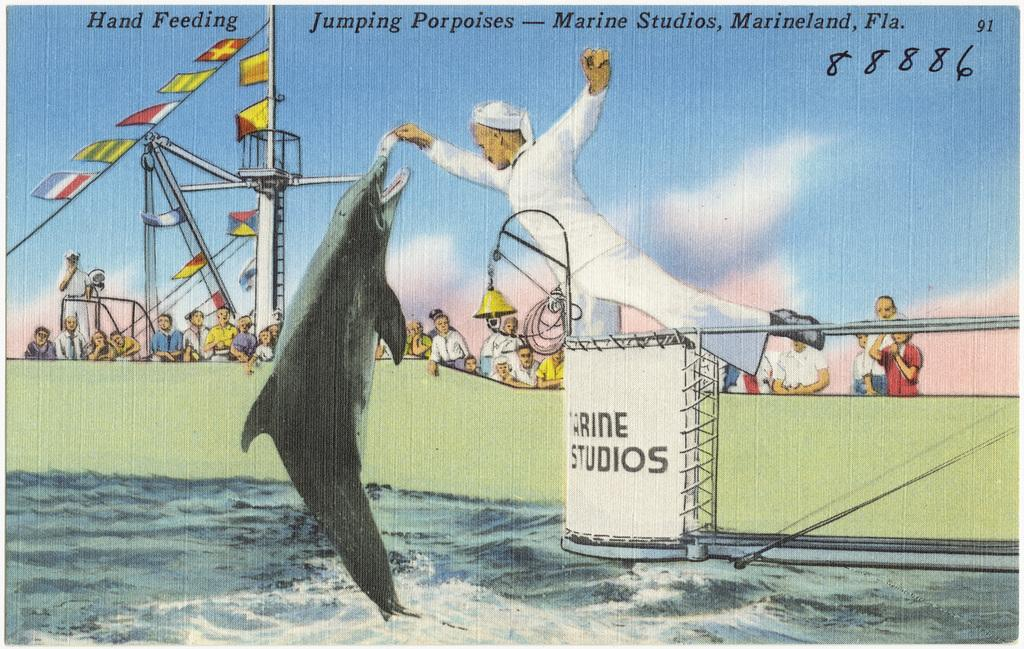What is the main subject of the poster in the image? The poster contains pictures of people, water, fish, and the sky. What other elements are present on the poster besides the images? There is text and flags on the poster. Can you see a pocket on the poster in the image? There is no pocket present on the poster; it contains pictures, text, and flags. Is there a guitar featured in any of the images on the poster? There is no guitar present in any of the images on the poster. 